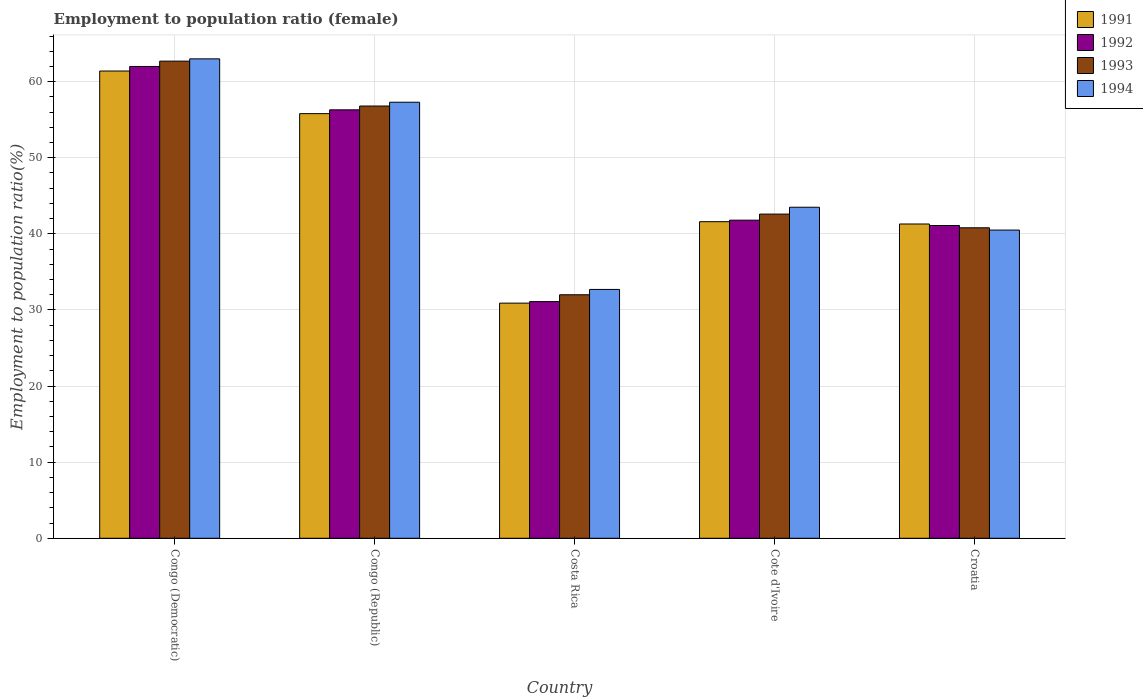How many different coloured bars are there?
Your answer should be compact. 4. How many groups of bars are there?
Make the answer very short. 5. Are the number of bars on each tick of the X-axis equal?
Your answer should be compact. Yes. How many bars are there on the 1st tick from the left?
Provide a short and direct response. 4. What is the label of the 4th group of bars from the left?
Offer a terse response. Cote d'Ivoire. In how many cases, is the number of bars for a given country not equal to the number of legend labels?
Your answer should be compact. 0. What is the employment to population ratio in 1994 in Costa Rica?
Provide a succinct answer. 32.7. Across all countries, what is the maximum employment to population ratio in 1991?
Make the answer very short. 61.4. In which country was the employment to population ratio in 1994 maximum?
Give a very brief answer. Congo (Democratic). In which country was the employment to population ratio in 1993 minimum?
Keep it short and to the point. Costa Rica. What is the total employment to population ratio in 1994 in the graph?
Provide a short and direct response. 237. What is the difference between the employment to population ratio in 1994 in Congo (Democratic) and the employment to population ratio in 1991 in Cote d'Ivoire?
Your answer should be very brief. 21.4. What is the average employment to population ratio in 1993 per country?
Offer a terse response. 46.98. What is the difference between the employment to population ratio of/in 1992 and employment to population ratio of/in 1991 in Cote d'Ivoire?
Your response must be concise. 0.2. What is the ratio of the employment to population ratio in 1994 in Congo (Republic) to that in Cote d'Ivoire?
Provide a short and direct response. 1.32. Is the employment to population ratio in 1992 in Cote d'Ivoire less than that in Croatia?
Provide a succinct answer. No. What is the difference between the highest and the second highest employment to population ratio in 1992?
Give a very brief answer. 14.5. What is the difference between the highest and the lowest employment to population ratio in 1994?
Give a very brief answer. 30.3. In how many countries, is the employment to population ratio in 1994 greater than the average employment to population ratio in 1994 taken over all countries?
Your response must be concise. 2. Is the sum of the employment to population ratio in 1994 in Costa Rica and Croatia greater than the maximum employment to population ratio in 1993 across all countries?
Your response must be concise. Yes. What does the 1st bar from the right in Congo (Democratic) represents?
Provide a succinct answer. 1994. Is it the case that in every country, the sum of the employment to population ratio in 1991 and employment to population ratio in 1992 is greater than the employment to population ratio in 1993?
Your response must be concise. Yes. What is the difference between two consecutive major ticks on the Y-axis?
Offer a very short reply. 10. Are the values on the major ticks of Y-axis written in scientific E-notation?
Your answer should be very brief. No. How many legend labels are there?
Your answer should be very brief. 4. What is the title of the graph?
Give a very brief answer. Employment to population ratio (female). What is the label or title of the X-axis?
Keep it short and to the point. Country. What is the label or title of the Y-axis?
Provide a succinct answer. Employment to population ratio(%). What is the Employment to population ratio(%) in 1991 in Congo (Democratic)?
Your answer should be compact. 61.4. What is the Employment to population ratio(%) of 1993 in Congo (Democratic)?
Provide a succinct answer. 62.7. What is the Employment to population ratio(%) in 1991 in Congo (Republic)?
Give a very brief answer. 55.8. What is the Employment to population ratio(%) in 1992 in Congo (Republic)?
Offer a very short reply. 56.3. What is the Employment to population ratio(%) of 1993 in Congo (Republic)?
Your answer should be compact. 56.8. What is the Employment to population ratio(%) in 1994 in Congo (Republic)?
Your answer should be very brief. 57.3. What is the Employment to population ratio(%) in 1991 in Costa Rica?
Offer a terse response. 30.9. What is the Employment to population ratio(%) of 1992 in Costa Rica?
Ensure brevity in your answer.  31.1. What is the Employment to population ratio(%) of 1993 in Costa Rica?
Your answer should be compact. 32. What is the Employment to population ratio(%) of 1994 in Costa Rica?
Provide a succinct answer. 32.7. What is the Employment to population ratio(%) in 1991 in Cote d'Ivoire?
Offer a very short reply. 41.6. What is the Employment to population ratio(%) of 1992 in Cote d'Ivoire?
Provide a short and direct response. 41.8. What is the Employment to population ratio(%) of 1993 in Cote d'Ivoire?
Ensure brevity in your answer.  42.6. What is the Employment to population ratio(%) in 1994 in Cote d'Ivoire?
Your response must be concise. 43.5. What is the Employment to population ratio(%) of 1991 in Croatia?
Your answer should be compact. 41.3. What is the Employment to population ratio(%) in 1992 in Croatia?
Offer a very short reply. 41.1. What is the Employment to population ratio(%) in 1993 in Croatia?
Ensure brevity in your answer.  40.8. What is the Employment to population ratio(%) of 1994 in Croatia?
Ensure brevity in your answer.  40.5. Across all countries, what is the maximum Employment to population ratio(%) in 1991?
Your answer should be very brief. 61.4. Across all countries, what is the maximum Employment to population ratio(%) in 1993?
Give a very brief answer. 62.7. Across all countries, what is the minimum Employment to population ratio(%) of 1991?
Provide a succinct answer. 30.9. Across all countries, what is the minimum Employment to population ratio(%) of 1992?
Offer a terse response. 31.1. Across all countries, what is the minimum Employment to population ratio(%) of 1993?
Your answer should be compact. 32. Across all countries, what is the minimum Employment to population ratio(%) of 1994?
Your answer should be very brief. 32.7. What is the total Employment to population ratio(%) of 1991 in the graph?
Your response must be concise. 231. What is the total Employment to population ratio(%) in 1992 in the graph?
Make the answer very short. 232.3. What is the total Employment to population ratio(%) in 1993 in the graph?
Make the answer very short. 234.9. What is the total Employment to population ratio(%) in 1994 in the graph?
Offer a terse response. 237. What is the difference between the Employment to population ratio(%) in 1992 in Congo (Democratic) and that in Congo (Republic)?
Offer a very short reply. 5.7. What is the difference between the Employment to population ratio(%) in 1993 in Congo (Democratic) and that in Congo (Republic)?
Offer a terse response. 5.9. What is the difference between the Employment to population ratio(%) in 1991 in Congo (Democratic) and that in Costa Rica?
Give a very brief answer. 30.5. What is the difference between the Employment to population ratio(%) in 1992 in Congo (Democratic) and that in Costa Rica?
Your response must be concise. 30.9. What is the difference between the Employment to population ratio(%) in 1993 in Congo (Democratic) and that in Costa Rica?
Keep it short and to the point. 30.7. What is the difference between the Employment to population ratio(%) in 1994 in Congo (Democratic) and that in Costa Rica?
Provide a short and direct response. 30.3. What is the difference between the Employment to population ratio(%) in 1991 in Congo (Democratic) and that in Cote d'Ivoire?
Provide a short and direct response. 19.8. What is the difference between the Employment to population ratio(%) of 1992 in Congo (Democratic) and that in Cote d'Ivoire?
Make the answer very short. 20.2. What is the difference between the Employment to population ratio(%) in 1993 in Congo (Democratic) and that in Cote d'Ivoire?
Offer a very short reply. 20.1. What is the difference between the Employment to population ratio(%) of 1994 in Congo (Democratic) and that in Cote d'Ivoire?
Provide a short and direct response. 19.5. What is the difference between the Employment to population ratio(%) of 1991 in Congo (Democratic) and that in Croatia?
Keep it short and to the point. 20.1. What is the difference between the Employment to population ratio(%) of 1992 in Congo (Democratic) and that in Croatia?
Your response must be concise. 20.9. What is the difference between the Employment to population ratio(%) in 1993 in Congo (Democratic) and that in Croatia?
Your answer should be very brief. 21.9. What is the difference between the Employment to population ratio(%) of 1994 in Congo (Democratic) and that in Croatia?
Provide a short and direct response. 22.5. What is the difference between the Employment to population ratio(%) in 1991 in Congo (Republic) and that in Costa Rica?
Your answer should be compact. 24.9. What is the difference between the Employment to population ratio(%) in 1992 in Congo (Republic) and that in Costa Rica?
Your answer should be very brief. 25.2. What is the difference between the Employment to population ratio(%) in 1993 in Congo (Republic) and that in Costa Rica?
Provide a succinct answer. 24.8. What is the difference between the Employment to population ratio(%) of 1994 in Congo (Republic) and that in Costa Rica?
Offer a terse response. 24.6. What is the difference between the Employment to population ratio(%) in 1993 in Congo (Republic) and that in Cote d'Ivoire?
Keep it short and to the point. 14.2. What is the difference between the Employment to population ratio(%) of 1994 in Congo (Republic) and that in Cote d'Ivoire?
Your answer should be compact. 13.8. What is the difference between the Employment to population ratio(%) of 1991 in Congo (Republic) and that in Croatia?
Provide a succinct answer. 14.5. What is the difference between the Employment to population ratio(%) of 1992 in Congo (Republic) and that in Croatia?
Your response must be concise. 15.2. What is the difference between the Employment to population ratio(%) in 1993 in Congo (Republic) and that in Croatia?
Ensure brevity in your answer.  16. What is the difference between the Employment to population ratio(%) in 1992 in Costa Rica and that in Cote d'Ivoire?
Your response must be concise. -10.7. What is the difference between the Employment to population ratio(%) in 1993 in Costa Rica and that in Cote d'Ivoire?
Offer a terse response. -10.6. What is the difference between the Employment to population ratio(%) in 1991 in Costa Rica and that in Croatia?
Provide a short and direct response. -10.4. What is the difference between the Employment to population ratio(%) of 1992 in Costa Rica and that in Croatia?
Give a very brief answer. -10. What is the difference between the Employment to population ratio(%) in 1991 in Cote d'Ivoire and that in Croatia?
Your response must be concise. 0.3. What is the difference between the Employment to population ratio(%) in 1993 in Cote d'Ivoire and that in Croatia?
Make the answer very short. 1.8. What is the difference between the Employment to population ratio(%) in 1994 in Cote d'Ivoire and that in Croatia?
Keep it short and to the point. 3. What is the difference between the Employment to population ratio(%) of 1991 in Congo (Democratic) and the Employment to population ratio(%) of 1993 in Congo (Republic)?
Make the answer very short. 4.6. What is the difference between the Employment to population ratio(%) of 1991 in Congo (Democratic) and the Employment to population ratio(%) of 1994 in Congo (Republic)?
Provide a short and direct response. 4.1. What is the difference between the Employment to population ratio(%) of 1992 in Congo (Democratic) and the Employment to population ratio(%) of 1993 in Congo (Republic)?
Keep it short and to the point. 5.2. What is the difference between the Employment to population ratio(%) of 1992 in Congo (Democratic) and the Employment to population ratio(%) of 1994 in Congo (Republic)?
Keep it short and to the point. 4.7. What is the difference between the Employment to population ratio(%) of 1993 in Congo (Democratic) and the Employment to population ratio(%) of 1994 in Congo (Republic)?
Keep it short and to the point. 5.4. What is the difference between the Employment to population ratio(%) in 1991 in Congo (Democratic) and the Employment to population ratio(%) in 1992 in Costa Rica?
Your answer should be very brief. 30.3. What is the difference between the Employment to population ratio(%) in 1991 in Congo (Democratic) and the Employment to population ratio(%) in 1993 in Costa Rica?
Your response must be concise. 29.4. What is the difference between the Employment to population ratio(%) of 1991 in Congo (Democratic) and the Employment to population ratio(%) of 1994 in Costa Rica?
Give a very brief answer. 28.7. What is the difference between the Employment to population ratio(%) of 1992 in Congo (Democratic) and the Employment to population ratio(%) of 1994 in Costa Rica?
Your response must be concise. 29.3. What is the difference between the Employment to population ratio(%) of 1991 in Congo (Democratic) and the Employment to population ratio(%) of 1992 in Cote d'Ivoire?
Offer a terse response. 19.6. What is the difference between the Employment to population ratio(%) in 1991 in Congo (Democratic) and the Employment to population ratio(%) in 1993 in Cote d'Ivoire?
Offer a terse response. 18.8. What is the difference between the Employment to population ratio(%) of 1992 in Congo (Democratic) and the Employment to population ratio(%) of 1993 in Cote d'Ivoire?
Offer a very short reply. 19.4. What is the difference between the Employment to population ratio(%) in 1993 in Congo (Democratic) and the Employment to population ratio(%) in 1994 in Cote d'Ivoire?
Keep it short and to the point. 19.2. What is the difference between the Employment to population ratio(%) in 1991 in Congo (Democratic) and the Employment to population ratio(%) in 1992 in Croatia?
Keep it short and to the point. 20.3. What is the difference between the Employment to population ratio(%) of 1991 in Congo (Democratic) and the Employment to population ratio(%) of 1993 in Croatia?
Keep it short and to the point. 20.6. What is the difference between the Employment to population ratio(%) of 1991 in Congo (Democratic) and the Employment to population ratio(%) of 1994 in Croatia?
Offer a terse response. 20.9. What is the difference between the Employment to population ratio(%) in 1992 in Congo (Democratic) and the Employment to population ratio(%) in 1993 in Croatia?
Your response must be concise. 21.2. What is the difference between the Employment to population ratio(%) in 1991 in Congo (Republic) and the Employment to population ratio(%) in 1992 in Costa Rica?
Give a very brief answer. 24.7. What is the difference between the Employment to population ratio(%) in 1991 in Congo (Republic) and the Employment to population ratio(%) in 1993 in Costa Rica?
Your answer should be compact. 23.8. What is the difference between the Employment to population ratio(%) of 1991 in Congo (Republic) and the Employment to population ratio(%) of 1994 in Costa Rica?
Your response must be concise. 23.1. What is the difference between the Employment to population ratio(%) of 1992 in Congo (Republic) and the Employment to population ratio(%) of 1993 in Costa Rica?
Keep it short and to the point. 24.3. What is the difference between the Employment to population ratio(%) in 1992 in Congo (Republic) and the Employment to population ratio(%) in 1994 in Costa Rica?
Your answer should be compact. 23.6. What is the difference between the Employment to population ratio(%) of 1993 in Congo (Republic) and the Employment to population ratio(%) of 1994 in Costa Rica?
Your answer should be very brief. 24.1. What is the difference between the Employment to population ratio(%) in 1991 in Congo (Republic) and the Employment to population ratio(%) in 1994 in Cote d'Ivoire?
Provide a short and direct response. 12.3. What is the difference between the Employment to population ratio(%) in 1992 in Congo (Republic) and the Employment to population ratio(%) in 1993 in Cote d'Ivoire?
Your answer should be very brief. 13.7. What is the difference between the Employment to population ratio(%) of 1992 in Congo (Republic) and the Employment to population ratio(%) of 1994 in Cote d'Ivoire?
Offer a terse response. 12.8. What is the difference between the Employment to population ratio(%) in 1991 in Congo (Republic) and the Employment to population ratio(%) in 1992 in Croatia?
Offer a terse response. 14.7. What is the difference between the Employment to population ratio(%) in 1991 in Congo (Republic) and the Employment to population ratio(%) in 1993 in Croatia?
Give a very brief answer. 15. What is the difference between the Employment to population ratio(%) in 1991 in Congo (Republic) and the Employment to population ratio(%) in 1994 in Croatia?
Your answer should be very brief. 15.3. What is the difference between the Employment to population ratio(%) in 1991 in Costa Rica and the Employment to population ratio(%) in 1993 in Cote d'Ivoire?
Your answer should be compact. -11.7. What is the difference between the Employment to population ratio(%) of 1991 in Costa Rica and the Employment to population ratio(%) of 1994 in Cote d'Ivoire?
Your answer should be very brief. -12.6. What is the difference between the Employment to population ratio(%) of 1992 in Costa Rica and the Employment to population ratio(%) of 1993 in Cote d'Ivoire?
Offer a terse response. -11.5. What is the difference between the Employment to population ratio(%) in 1991 in Costa Rica and the Employment to population ratio(%) in 1994 in Croatia?
Your answer should be very brief. -9.6. What is the difference between the Employment to population ratio(%) of 1992 in Costa Rica and the Employment to population ratio(%) of 1993 in Croatia?
Provide a succinct answer. -9.7. What is the difference between the Employment to population ratio(%) of 1992 in Costa Rica and the Employment to population ratio(%) of 1994 in Croatia?
Ensure brevity in your answer.  -9.4. What is the difference between the Employment to population ratio(%) of 1992 in Cote d'Ivoire and the Employment to population ratio(%) of 1994 in Croatia?
Offer a very short reply. 1.3. What is the average Employment to population ratio(%) of 1991 per country?
Your response must be concise. 46.2. What is the average Employment to population ratio(%) in 1992 per country?
Your answer should be compact. 46.46. What is the average Employment to population ratio(%) of 1993 per country?
Keep it short and to the point. 46.98. What is the average Employment to population ratio(%) of 1994 per country?
Offer a terse response. 47.4. What is the difference between the Employment to population ratio(%) of 1991 and Employment to population ratio(%) of 1992 in Congo (Democratic)?
Give a very brief answer. -0.6. What is the difference between the Employment to population ratio(%) in 1991 and Employment to population ratio(%) in 1993 in Congo (Democratic)?
Offer a very short reply. -1.3. What is the difference between the Employment to population ratio(%) in 1992 and Employment to population ratio(%) in 1993 in Congo (Democratic)?
Your answer should be very brief. -0.7. What is the difference between the Employment to population ratio(%) in 1993 and Employment to population ratio(%) in 1994 in Congo (Democratic)?
Offer a terse response. -0.3. What is the difference between the Employment to population ratio(%) of 1991 and Employment to population ratio(%) of 1993 in Congo (Republic)?
Give a very brief answer. -1. What is the difference between the Employment to population ratio(%) of 1991 and Employment to population ratio(%) of 1994 in Congo (Republic)?
Provide a short and direct response. -1.5. What is the difference between the Employment to population ratio(%) in 1991 and Employment to population ratio(%) in 1992 in Costa Rica?
Your answer should be very brief. -0.2. What is the difference between the Employment to population ratio(%) in 1991 and Employment to population ratio(%) in 1993 in Costa Rica?
Your answer should be very brief. -1.1. What is the difference between the Employment to population ratio(%) in 1991 and Employment to population ratio(%) in 1994 in Costa Rica?
Offer a very short reply. -1.8. What is the difference between the Employment to population ratio(%) in 1992 and Employment to population ratio(%) in 1994 in Costa Rica?
Keep it short and to the point. -1.6. What is the difference between the Employment to population ratio(%) in 1993 and Employment to population ratio(%) in 1994 in Costa Rica?
Offer a very short reply. -0.7. What is the difference between the Employment to population ratio(%) of 1991 and Employment to population ratio(%) of 1992 in Cote d'Ivoire?
Your answer should be compact. -0.2. What is the difference between the Employment to population ratio(%) of 1991 and Employment to population ratio(%) of 1993 in Cote d'Ivoire?
Provide a succinct answer. -1. What is the difference between the Employment to population ratio(%) of 1991 and Employment to population ratio(%) of 1994 in Cote d'Ivoire?
Offer a terse response. -1.9. What is the difference between the Employment to population ratio(%) in 1992 and Employment to population ratio(%) in 1993 in Cote d'Ivoire?
Ensure brevity in your answer.  -0.8. What is the difference between the Employment to population ratio(%) in 1992 and Employment to population ratio(%) in 1994 in Cote d'Ivoire?
Your answer should be compact. -1.7. What is the difference between the Employment to population ratio(%) in 1993 and Employment to population ratio(%) in 1994 in Cote d'Ivoire?
Ensure brevity in your answer.  -0.9. What is the difference between the Employment to population ratio(%) of 1991 and Employment to population ratio(%) of 1994 in Croatia?
Keep it short and to the point. 0.8. What is the difference between the Employment to population ratio(%) in 1992 and Employment to population ratio(%) in 1994 in Croatia?
Offer a terse response. 0.6. What is the difference between the Employment to population ratio(%) of 1993 and Employment to population ratio(%) of 1994 in Croatia?
Ensure brevity in your answer.  0.3. What is the ratio of the Employment to population ratio(%) in 1991 in Congo (Democratic) to that in Congo (Republic)?
Make the answer very short. 1.1. What is the ratio of the Employment to population ratio(%) of 1992 in Congo (Democratic) to that in Congo (Republic)?
Your answer should be compact. 1.1. What is the ratio of the Employment to population ratio(%) in 1993 in Congo (Democratic) to that in Congo (Republic)?
Make the answer very short. 1.1. What is the ratio of the Employment to population ratio(%) of 1994 in Congo (Democratic) to that in Congo (Republic)?
Make the answer very short. 1.1. What is the ratio of the Employment to population ratio(%) in 1991 in Congo (Democratic) to that in Costa Rica?
Provide a succinct answer. 1.99. What is the ratio of the Employment to population ratio(%) of 1992 in Congo (Democratic) to that in Costa Rica?
Offer a very short reply. 1.99. What is the ratio of the Employment to population ratio(%) in 1993 in Congo (Democratic) to that in Costa Rica?
Your answer should be compact. 1.96. What is the ratio of the Employment to population ratio(%) in 1994 in Congo (Democratic) to that in Costa Rica?
Keep it short and to the point. 1.93. What is the ratio of the Employment to population ratio(%) of 1991 in Congo (Democratic) to that in Cote d'Ivoire?
Provide a succinct answer. 1.48. What is the ratio of the Employment to population ratio(%) in 1992 in Congo (Democratic) to that in Cote d'Ivoire?
Make the answer very short. 1.48. What is the ratio of the Employment to population ratio(%) of 1993 in Congo (Democratic) to that in Cote d'Ivoire?
Ensure brevity in your answer.  1.47. What is the ratio of the Employment to population ratio(%) of 1994 in Congo (Democratic) to that in Cote d'Ivoire?
Provide a succinct answer. 1.45. What is the ratio of the Employment to population ratio(%) in 1991 in Congo (Democratic) to that in Croatia?
Keep it short and to the point. 1.49. What is the ratio of the Employment to population ratio(%) of 1992 in Congo (Democratic) to that in Croatia?
Your answer should be compact. 1.51. What is the ratio of the Employment to population ratio(%) in 1993 in Congo (Democratic) to that in Croatia?
Offer a terse response. 1.54. What is the ratio of the Employment to population ratio(%) of 1994 in Congo (Democratic) to that in Croatia?
Ensure brevity in your answer.  1.56. What is the ratio of the Employment to population ratio(%) of 1991 in Congo (Republic) to that in Costa Rica?
Make the answer very short. 1.81. What is the ratio of the Employment to population ratio(%) in 1992 in Congo (Republic) to that in Costa Rica?
Your answer should be very brief. 1.81. What is the ratio of the Employment to population ratio(%) of 1993 in Congo (Republic) to that in Costa Rica?
Keep it short and to the point. 1.77. What is the ratio of the Employment to population ratio(%) of 1994 in Congo (Republic) to that in Costa Rica?
Your response must be concise. 1.75. What is the ratio of the Employment to population ratio(%) in 1991 in Congo (Republic) to that in Cote d'Ivoire?
Provide a short and direct response. 1.34. What is the ratio of the Employment to population ratio(%) in 1992 in Congo (Republic) to that in Cote d'Ivoire?
Keep it short and to the point. 1.35. What is the ratio of the Employment to population ratio(%) in 1994 in Congo (Republic) to that in Cote d'Ivoire?
Provide a succinct answer. 1.32. What is the ratio of the Employment to population ratio(%) of 1991 in Congo (Republic) to that in Croatia?
Offer a terse response. 1.35. What is the ratio of the Employment to population ratio(%) of 1992 in Congo (Republic) to that in Croatia?
Keep it short and to the point. 1.37. What is the ratio of the Employment to population ratio(%) of 1993 in Congo (Republic) to that in Croatia?
Your response must be concise. 1.39. What is the ratio of the Employment to population ratio(%) of 1994 in Congo (Republic) to that in Croatia?
Your answer should be compact. 1.41. What is the ratio of the Employment to population ratio(%) of 1991 in Costa Rica to that in Cote d'Ivoire?
Provide a short and direct response. 0.74. What is the ratio of the Employment to population ratio(%) in 1992 in Costa Rica to that in Cote d'Ivoire?
Provide a short and direct response. 0.74. What is the ratio of the Employment to population ratio(%) of 1993 in Costa Rica to that in Cote d'Ivoire?
Make the answer very short. 0.75. What is the ratio of the Employment to population ratio(%) of 1994 in Costa Rica to that in Cote d'Ivoire?
Your answer should be very brief. 0.75. What is the ratio of the Employment to population ratio(%) in 1991 in Costa Rica to that in Croatia?
Your answer should be compact. 0.75. What is the ratio of the Employment to population ratio(%) of 1992 in Costa Rica to that in Croatia?
Offer a very short reply. 0.76. What is the ratio of the Employment to population ratio(%) in 1993 in Costa Rica to that in Croatia?
Your response must be concise. 0.78. What is the ratio of the Employment to population ratio(%) in 1994 in Costa Rica to that in Croatia?
Your answer should be compact. 0.81. What is the ratio of the Employment to population ratio(%) in 1991 in Cote d'Ivoire to that in Croatia?
Give a very brief answer. 1.01. What is the ratio of the Employment to population ratio(%) of 1992 in Cote d'Ivoire to that in Croatia?
Keep it short and to the point. 1.02. What is the ratio of the Employment to population ratio(%) of 1993 in Cote d'Ivoire to that in Croatia?
Offer a very short reply. 1.04. What is the ratio of the Employment to population ratio(%) in 1994 in Cote d'Ivoire to that in Croatia?
Your response must be concise. 1.07. What is the difference between the highest and the lowest Employment to population ratio(%) in 1991?
Your answer should be very brief. 30.5. What is the difference between the highest and the lowest Employment to population ratio(%) in 1992?
Your answer should be very brief. 30.9. What is the difference between the highest and the lowest Employment to population ratio(%) in 1993?
Make the answer very short. 30.7. What is the difference between the highest and the lowest Employment to population ratio(%) in 1994?
Your answer should be compact. 30.3. 